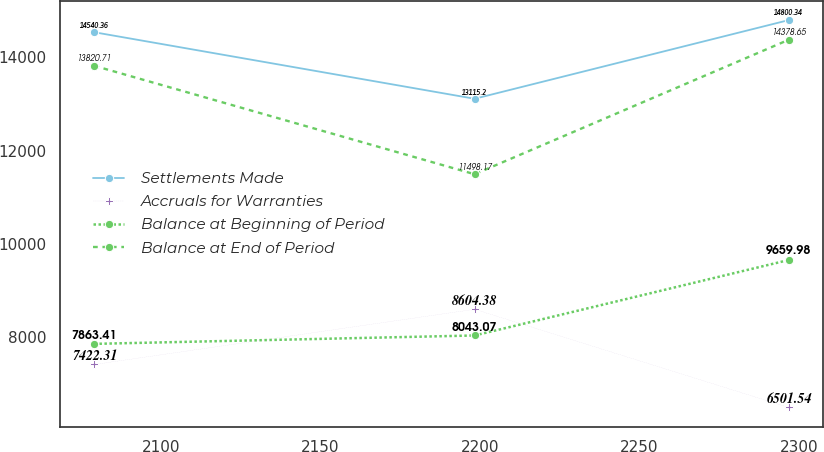<chart> <loc_0><loc_0><loc_500><loc_500><line_chart><ecel><fcel>Settlements Made<fcel>Accruals for Warranties<fcel>Balance at Beginning of Period<fcel>Balance at End of Period<nl><fcel>2079.13<fcel>14540.4<fcel>7422.31<fcel>7863.41<fcel>13820.7<nl><fcel>2198.35<fcel>13115.2<fcel>8604.38<fcel>8043.07<fcel>11498.2<nl><fcel>2296.81<fcel>14800.3<fcel>6501.54<fcel>9659.98<fcel>14378.6<nl></chart> 